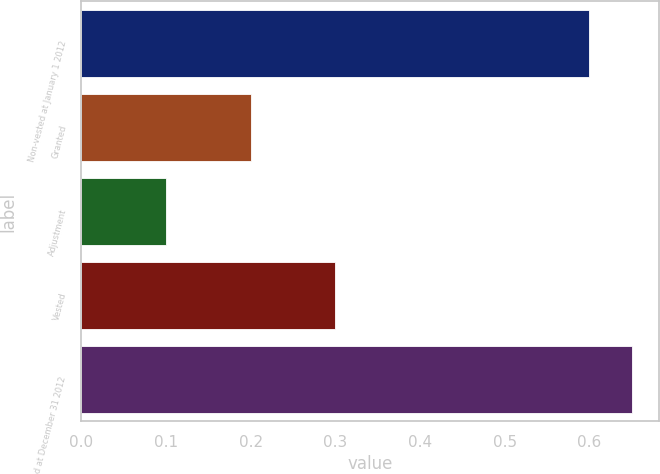Convert chart to OTSL. <chart><loc_0><loc_0><loc_500><loc_500><bar_chart><fcel>Non-vested at January 1 2012<fcel>Granted<fcel>Adjustment<fcel>Vested<fcel>Non-vested at December 31 2012<nl><fcel>0.6<fcel>0.2<fcel>0.1<fcel>0.3<fcel>0.65<nl></chart> 